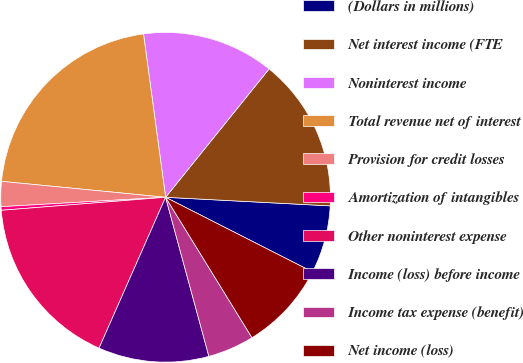Convert chart. <chart><loc_0><loc_0><loc_500><loc_500><pie_chart><fcel>(Dollars in millions)<fcel>Net interest income (FTE<fcel>Noninterest income<fcel>Total revenue net of interest<fcel>Provision for credit losses<fcel>Amortization of intangibles<fcel>Other noninterest expense<fcel>Income (loss) before income<fcel>Income tax expense (benefit)<fcel>Net income (loss)<nl><fcel>6.65%<fcel>15.03%<fcel>12.94%<fcel>21.32%<fcel>2.45%<fcel>0.35%<fcel>17.13%<fcel>10.84%<fcel>4.55%<fcel>8.74%<nl></chart> 